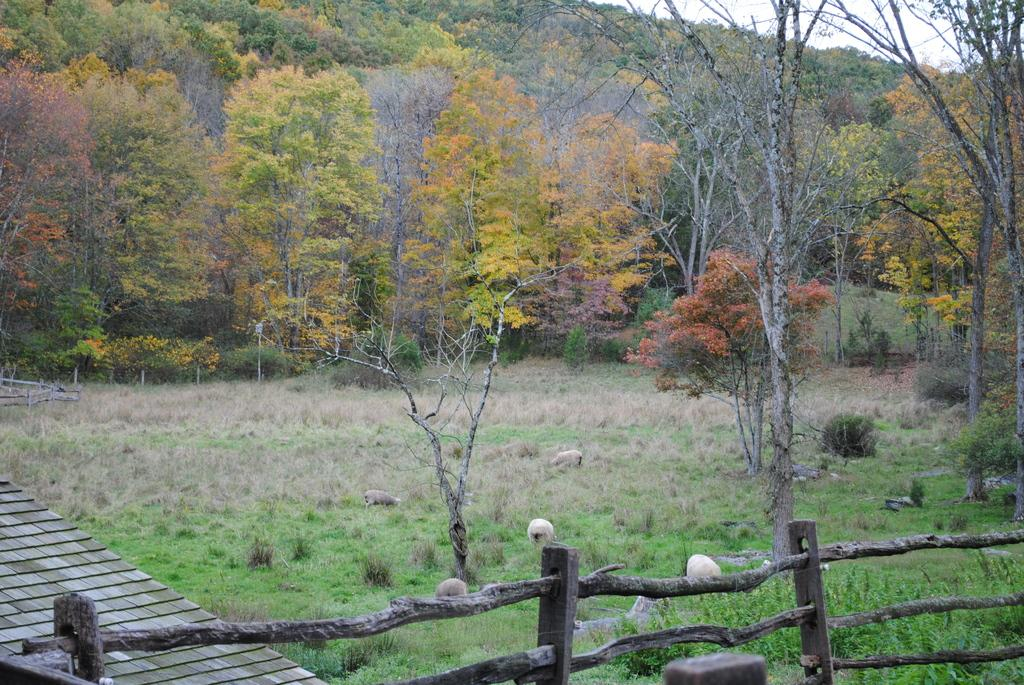What type of barrier can be seen in the image? There is a fence in the image. What type of vegetation is present in the image? There is grass, plants, and trees in the image. What type of terrain is visible in the image? There are stones and mountains in the image. What part of the natural environment is visible in the image? The sky is visible in the image. Based on the presence of the sun and the absence of artificial lighting, when do you think the image was taken? The image was likely taken during the day. How many babies are playing with gold coins in the image? There are no babies or gold coins present in the image. Are the friends in the image having a picnic together? There is no indication of friends or a picnic in the image. 